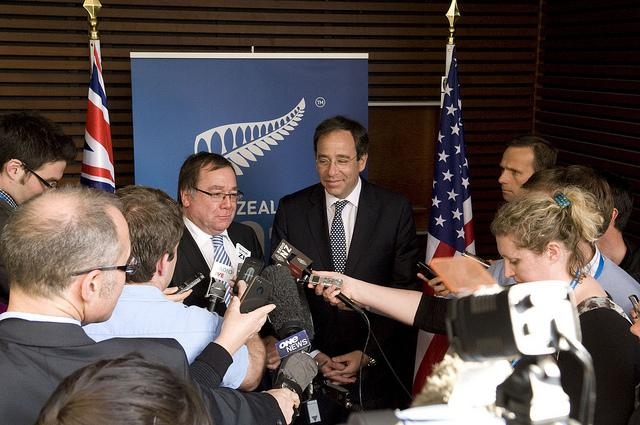What does the NZ on the microphone stand for? Please explain your reasoning. new zealand. This stands for the country they are from. 